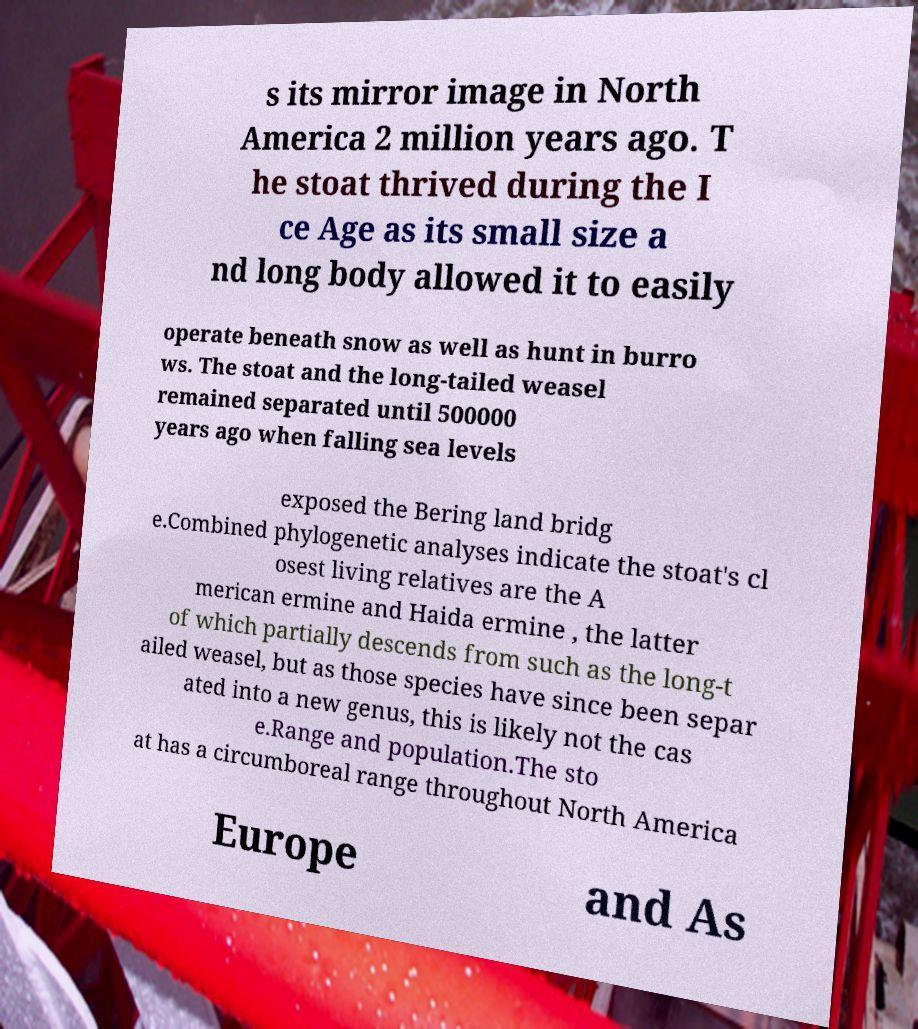Could you extract and type out the text from this image? s its mirror image in North America 2 million years ago. T he stoat thrived during the I ce Age as its small size a nd long body allowed it to easily operate beneath snow as well as hunt in burro ws. The stoat and the long-tailed weasel remained separated until 500000 years ago when falling sea levels exposed the Bering land bridg e.Combined phylogenetic analyses indicate the stoat's cl osest living relatives are the A merican ermine and Haida ermine , the latter of which partially descends from such as the long-t ailed weasel, but as those species have since been separ ated into a new genus, this is likely not the cas e.Range and population.The sto at has a circumboreal range throughout North America Europe and As 